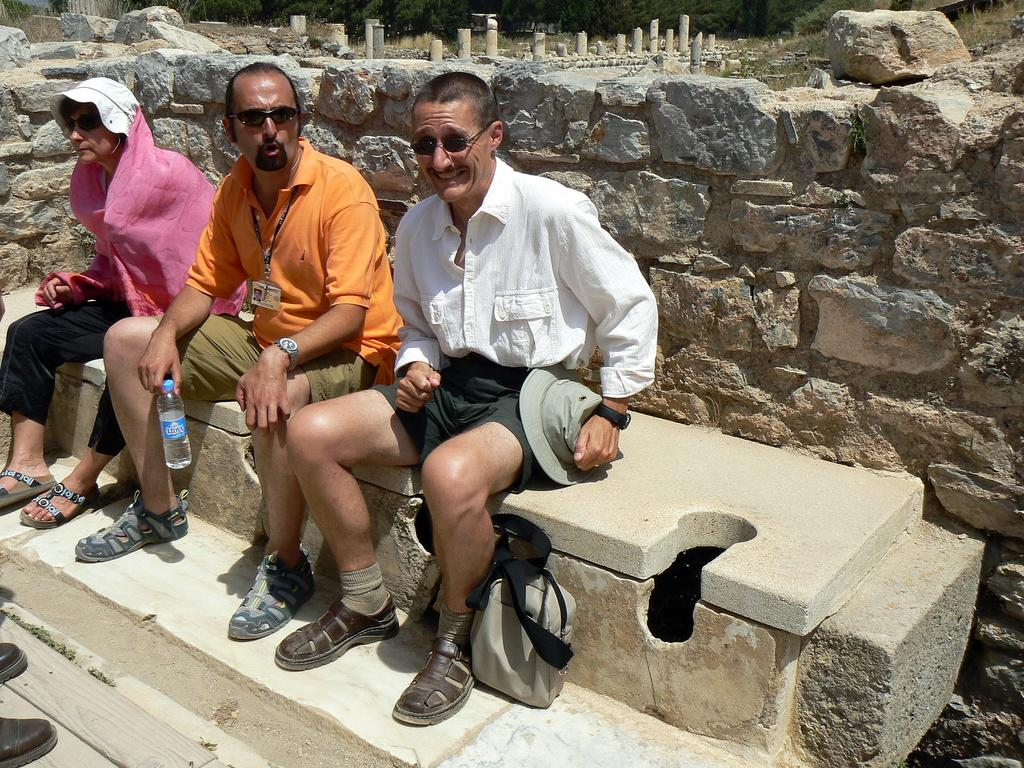What are the people in the image doing? The people in the image are sitting. What can be seen behind the people? There is a wall, rocks, grass, poles, and trees visible in the background of the image. What type of quill is being used by the person sitting on the left? There is no quill present in the image. What color are the trousers of the person sitting on the right? There is no mention of the people's clothing in the provided facts, so we cannot determine the color of their trousers. 